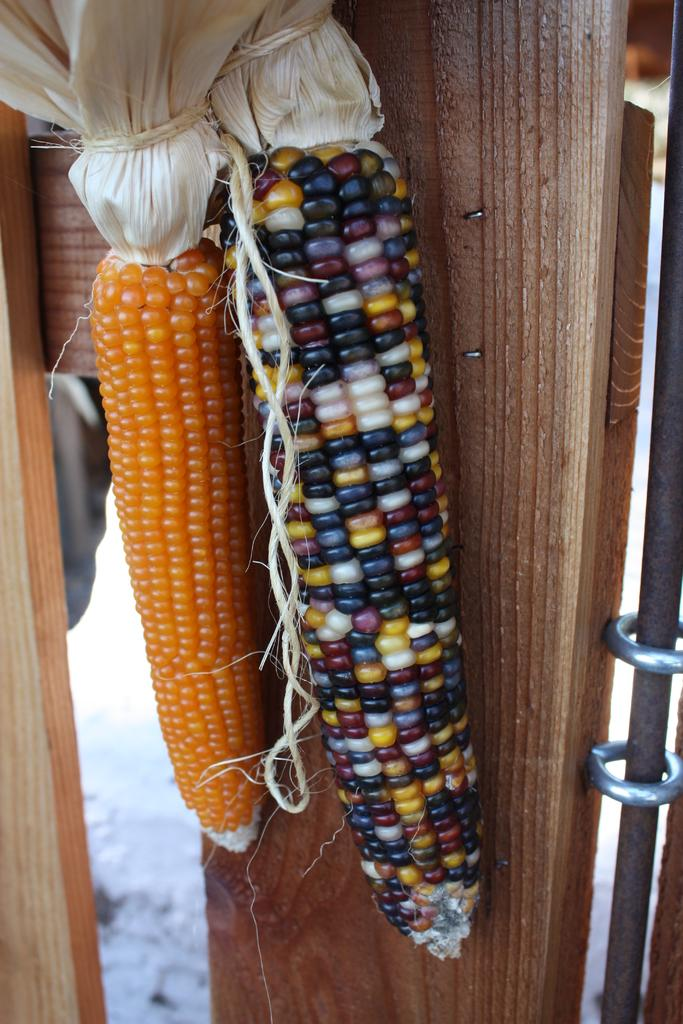How many corns are present in the image? There are two corns in the image. What is the color of one of the corns? One corn is of orange color. How can the other corn be described in terms of color? The other corn has different colors. How many kittens are playing with the corns in the image? There are no kittens present in the image; it only features two corns. What type of cannon is visible in the image? There is no cannon present in the image. 